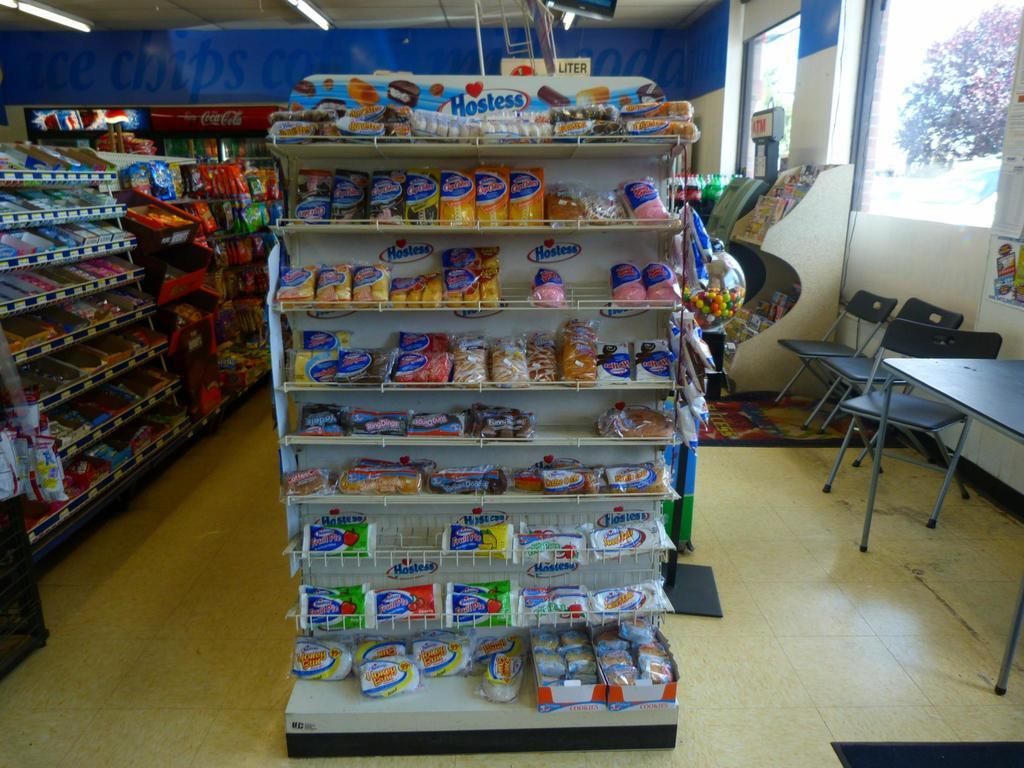Provide a one-sentence caption for the provided image. An end unit display in a store for Hostess snacks. 